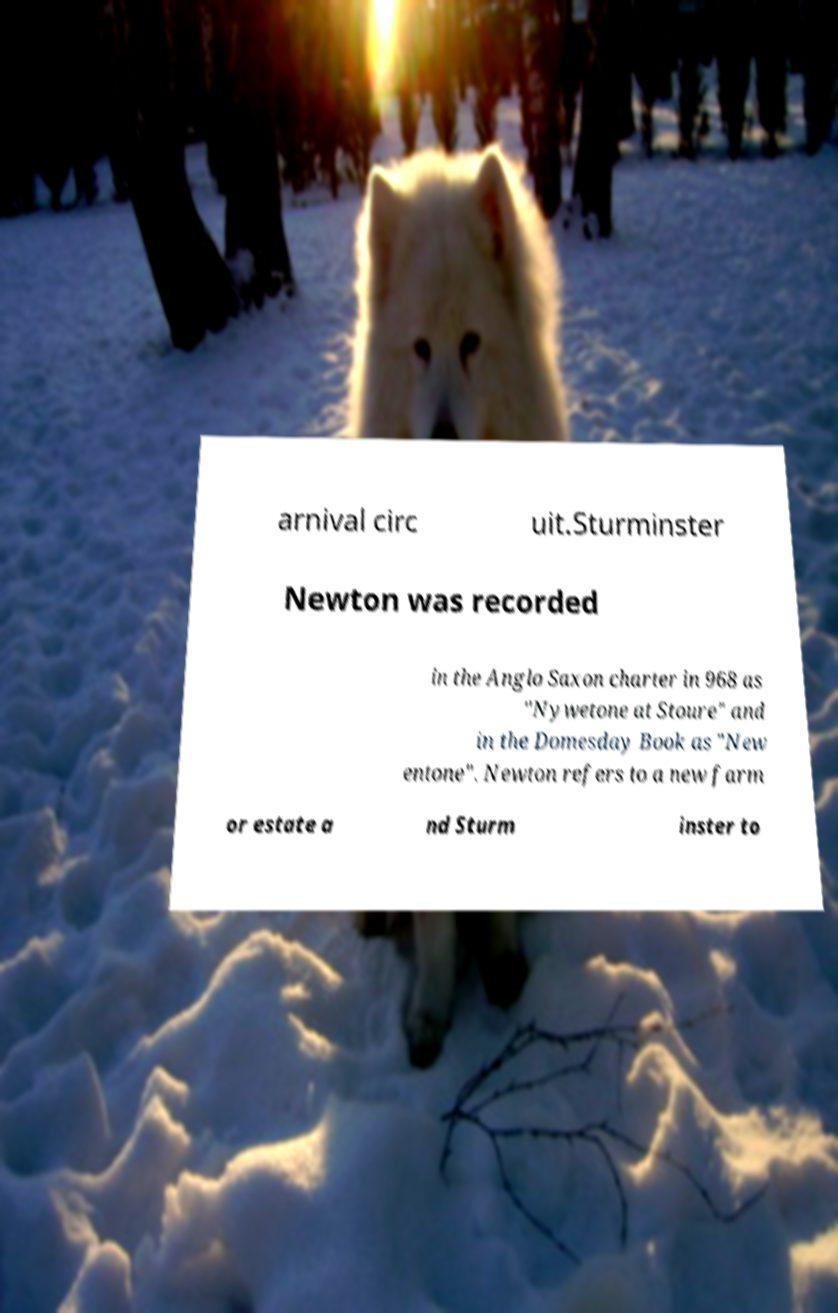Could you assist in decoding the text presented in this image and type it out clearly? arnival circ uit.Sturminster Newton was recorded in the Anglo Saxon charter in 968 as "Nywetone at Stoure" and in the Domesday Book as "New entone". Newton refers to a new farm or estate a nd Sturm inster to 